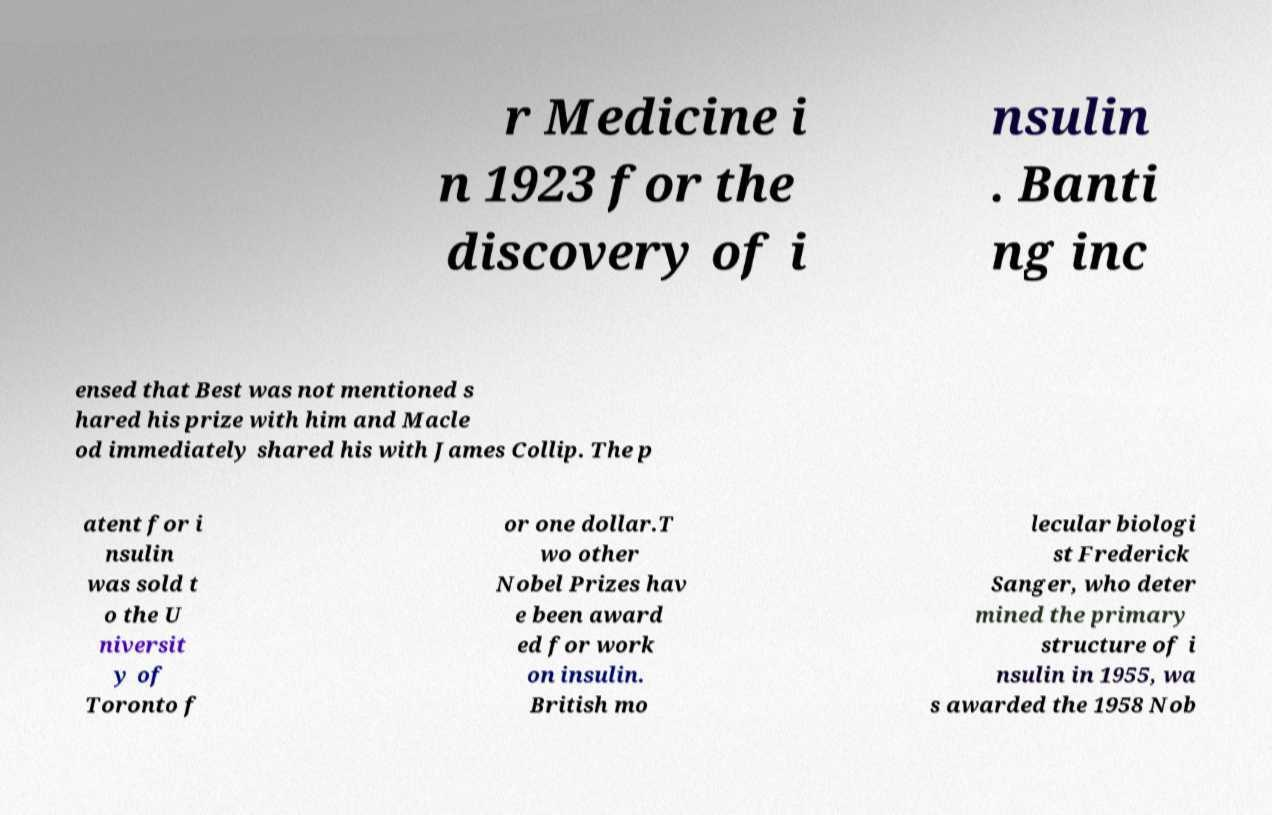Can you read and provide the text displayed in the image?This photo seems to have some interesting text. Can you extract and type it out for me? r Medicine i n 1923 for the discovery of i nsulin . Banti ng inc ensed that Best was not mentioned s hared his prize with him and Macle od immediately shared his with James Collip. The p atent for i nsulin was sold t o the U niversit y of Toronto f or one dollar.T wo other Nobel Prizes hav e been award ed for work on insulin. British mo lecular biologi st Frederick Sanger, who deter mined the primary structure of i nsulin in 1955, wa s awarded the 1958 Nob 